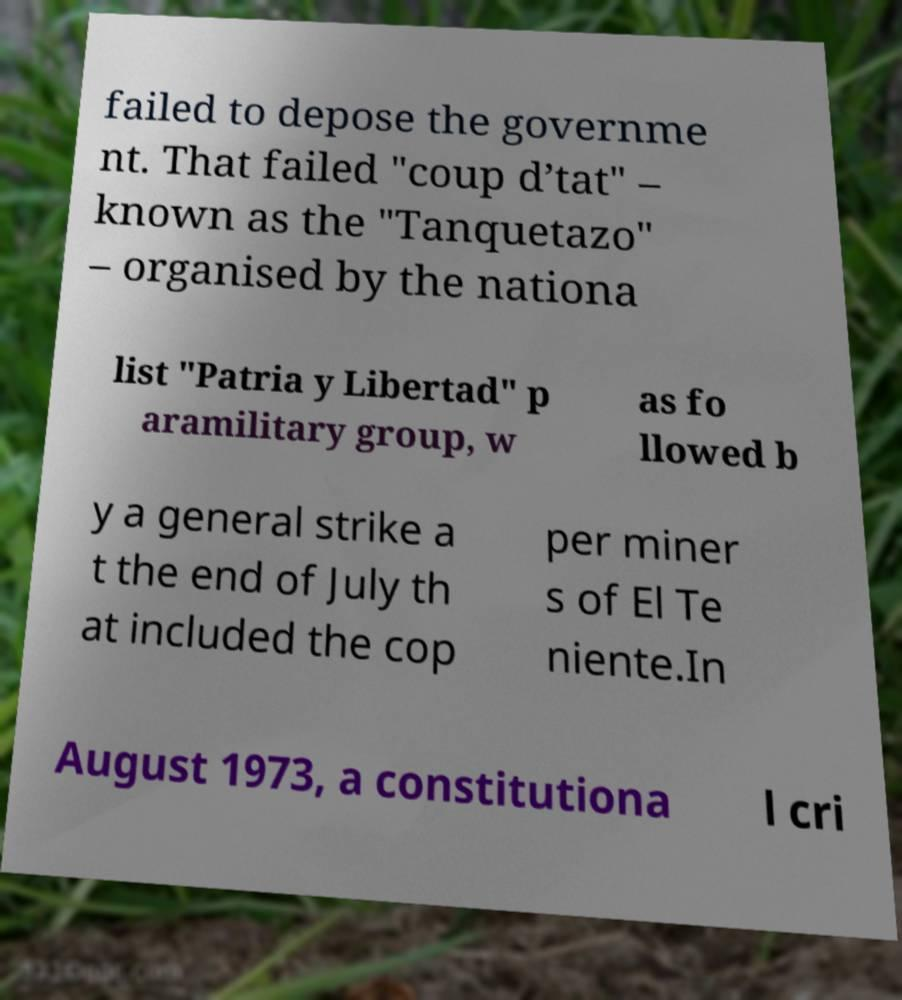Please identify and transcribe the text found in this image. failed to depose the governme nt. That failed "coup d’tat" – known as the "Tanquetazo" – organised by the nationa list "Patria y Libertad" p aramilitary group, w as fo llowed b y a general strike a t the end of July th at included the cop per miner s of El Te niente.In August 1973, a constitutiona l cri 